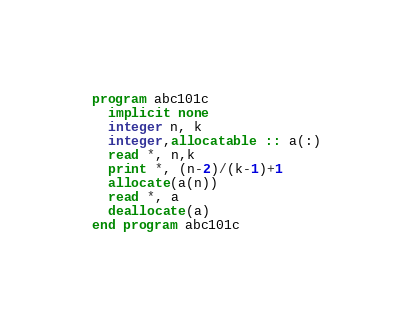Convert code to text. <code><loc_0><loc_0><loc_500><loc_500><_FORTRAN_>program abc101c
  implicit none
  integer n, k
  integer,allocatable :: a(:)
  read *, n,k
  print *, (n-2)/(k-1)+1
  allocate(a(n))
  read *, a
  deallocate(a)
end program abc101c
</code> 